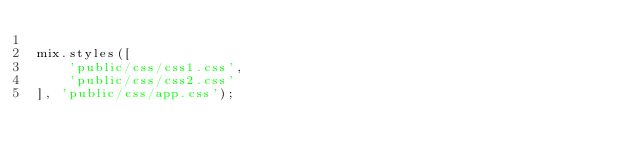<code> <loc_0><loc_0><loc_500><loc_500><_JavaScript_>
mix.styles([
    'public/css/css1.css',
    'public/css/css2.css'
], 'public/css/app.css');
</code> 